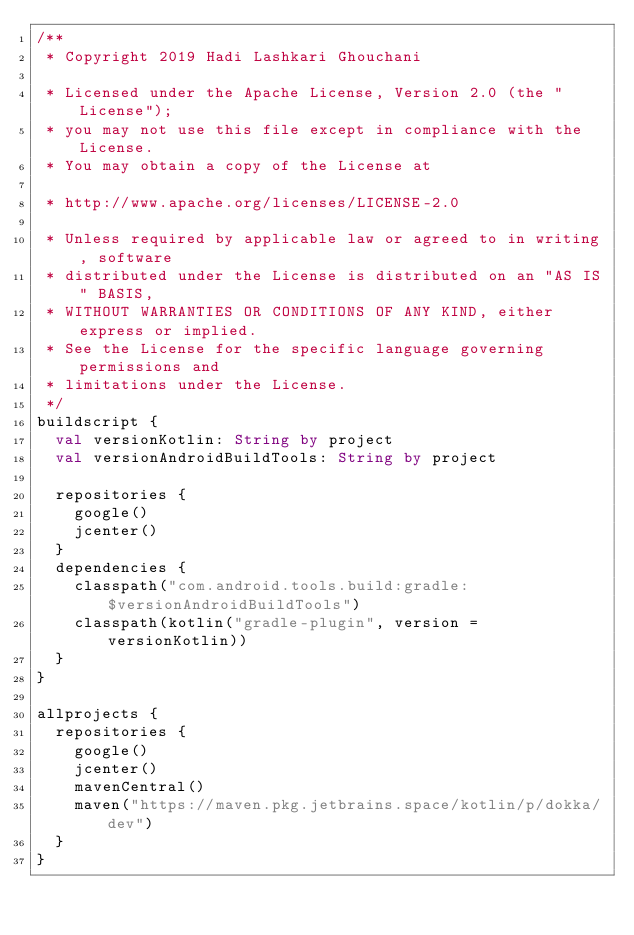<code> <loc_0><loc_0><loc_500><loc_500><_Kotlin_>/**
 * Copyright 2019 Hadi Lashkari Ghouchani

 * Licensed under the Apache License, Version 2.0 (the "License");
 * you may not use this file except in compliance with the License.
 * You may obtain a copy of the License at

 * http://www.apache.org/licenses/LICENSE-2.0

 * Unless required by applicable law or agreed to in writing, software
 * distributed under the License is distributed on an "AS IS" BASIS,
 * WITHOUT WARRANTIES OR CONDITIONS OF ANY KIND, either express or implied.
 * See the License for the specific language governing permissions and
 * limitations under the License.
 */
buildscript {
  val versionKotlin: String by project
  val versionAndroidBuildTools: String by project

  repositories {
    google()
    jcenter()
  }
  dependencies {
    classpath("com.android.tools.build:gradle:$versionAndroidBuildTools")
    classpath(kotlin("gradle-plugin", version = versionKotlin))
  }
}

allprojects {
  repositories {
    google()
    jcenter()
    mavenCentral()
    maven("https://maven.pkg.jetbrains.space/kotlin/p/dokka/dev")
  }
}
</code> 